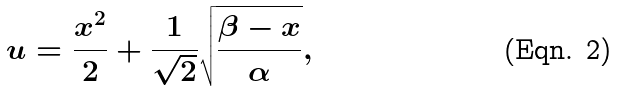<formula> <loc_0><loc_0><loc_500><loc_500>u = \frac { x ^ { 2 } } { 2 } + \frac { 1 } { \sqrt { 2 } } \sqrt { \frac { \beta - x } { \alpha } } ,</formula> 